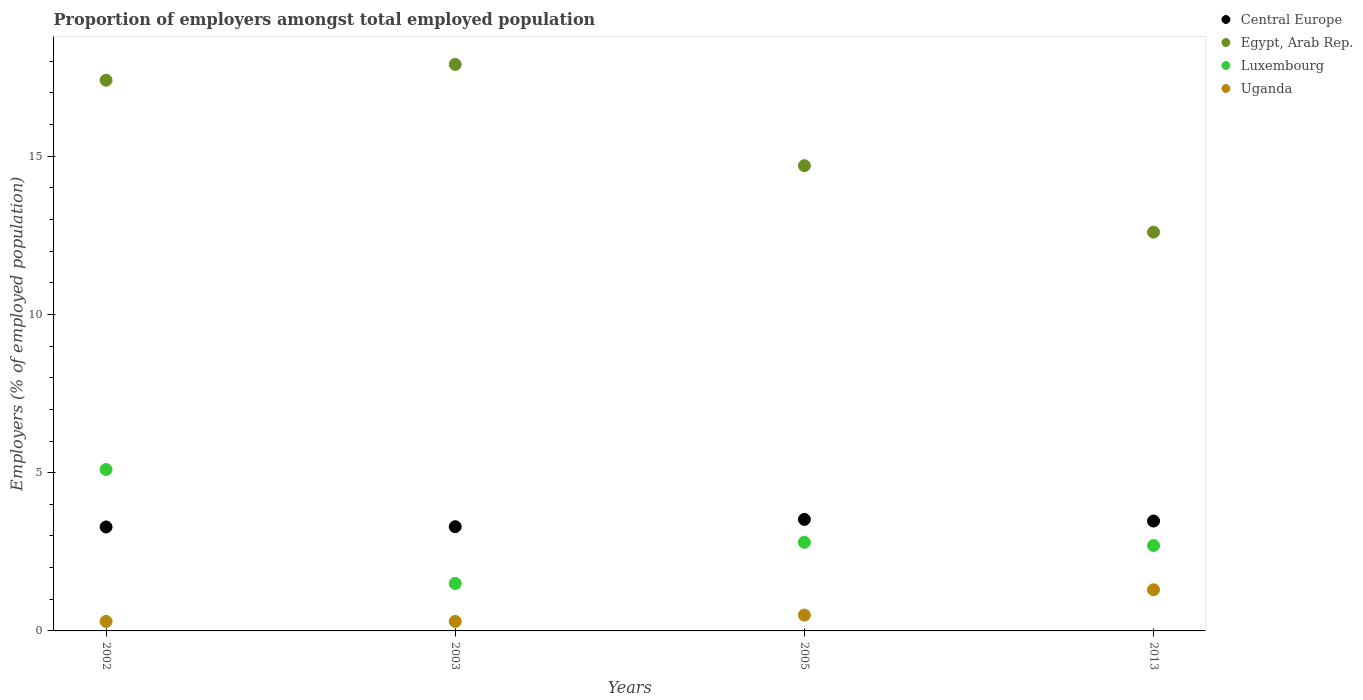How many different coloured dotlines are there?
Give a very brief answer. 4. What is the proportion of employers in Luxembourg in 2003?
Provide a succinct answer. 1.5. Across all years, what is the maximum proportion of employers in Uganda?
Offer a terse response. 1.3. Across all years, what is the minimum proportion of employers in Uganda?
Offer a terse response. 0.3. In which year was the proportion of employers in Luxembourg minimum?
Give a very brief answer. 2003. What is the total proportion of employers in Central Europe in the graph?
Offer a terse response. 13.57. What is the difference between the proportion of employers in Uganda in 2002 and that in 2013?
Offer a terse response. -1. What is the difference between the proportion of employers in Uganda in 2003 and the proportion of employers in Luxembourg in 2013?
Provide a short and direct response. -2.4. What is the average proportion of employers in Egypt, Arab Rep. per year?
Your answer should be compact. 15.65. In the year 2013, what is the difference between the proportion of employers in Egypt, Arab Rep. and proportion of employers in Luxembourg?
Provide a short and direct response. 9.9. What is the ratio of the proportion of employers in Luxembourg in 2003 to that in 2005?
Keep it short and to the point. 0.54. Is the difference between the proportion of employers in Egypt, Arab Rep. in 2002 and 2013 greater than the difference between the proportion of employers in Luxembourg in 2002 and 2013?
Make the answer very short. Yes. What is the difference between the highest and the second highest proportion of employers in Luxembourg?
Keep it short and to the point. 2.3. What is the difference between the highest and the lowest proportion of employers in Central Europe?
Provide a succinct answer. 0.24. In how many years, is the proportion of employers in Luxembourg greater than the average proportion of employers in Luxembourg taken over all years?
Offer a terse response. 1. Is it the case that in every year, the sum of the proportion of employers in Egypt, Arab Rep. and proportion of employers in Luxembourg  is greater than the sum of proportion of employers in Uganda and proportion of employers in Central Europe?
Provide a succinct answer. Yes. Does the proportion of employers in Luxembourg monotonically increase over the years?
Make the answer very short. No. Is the proportion of employers in Luxembourg strictly greater than the proportion of employers in Central Europe over the years?
Give a very brief answer. No. Is the proportion of employers in Central Europe strictly less than the proportion of employers in Luxembourg over the years?
Keep it short and to the point. No. How many dotlines are there?
Your answer should be compact. 4. What is the difference between two consecutive major ticks on the Y-axis?
Keep it short and to the point. 5. Are the values on the major ticks of Y-axis written in scientific E-notation?
Your answer should be very brief. No. Does the graph contain any zero values?
Offer a terse response. No. Where does the legend appear in the graph?
Your answer should be compact. Top right. How many legend labels are there?
Give a very brief answer. 4. What is the title of the graph?
Keep it short and to the point. Proportion of employers amongst total employed population. What is the label or title of the X-axis?
Make the answer very short. Years. What is the label or title of the Y-axis?
Offer a very short reply. Employers (% of employed population). What is the Employers (% of employed population) of Central Europe in 2002?
Your answer should be compact. 3.28. What is the Employers (% of employed population) of Egypt, Arab Rep. in 2002?
Your answer should be compact. 17.4. What is the Employers (% of employed population) in Luxembourg in 2002?
Make the answer very short. 5.1. What is the Employers (% of employed population) of Uganda in 2002?
Make the answer very short. 0.3. What is the Employers (% of employed population) in Central Europe in 2003?
Provide a short and direct response. 3.29. What is the Employers (% of employed population) in Egypt, Arab Rep. in 2003?
Provide a short and direct response. 17.9. What is the Employers (% of employed population) in Luxembourg in 2003?
Your answer should be very brief. 1.5. What is the Employers (% of employed population) of Uganda in 2003?
Offer a terse response. 0.3. What is the Employers (% of employed population) of Central Europe in 2005?
Keep it short and to the point. 3.52. What is the Employers (% of employed population) in Egypt, Arab Rep. in 2005?
Keep it short and to the point. 14.7. What is the Employers (% of employed population) of Luxembourg in 2005?
Keep it short and to the point. 2.8. What is the Employers (% of employed population) in Central Europe in 2013?
Ensure brevity in your answer.  3.47. What is the Employers (% of employed population) in Egypt, Arab Rep. in 2013?
Provide a succinct answer. 12.6. What is the Employers (% of employed population) in Luxembourg in 2013?
Keep it short and to the point. 2.7. What is the Employers (% of employed population) in Uganda in 2013?
Keep it short and to the point. 1.3. Across all years, what is the maximum Employers (% of employed population) in Central Europe?
Provide a short and direct response. 3.52. Across all years, what is the maximum Employers (% of employed population) in Egypt, Arab Rep.?
Give a very brief answer. 17.9. Across all years, what is the maximum Employers (% of employed population) in Luxembourg?
Ensure brevity in your answer.  5.1. Across all years, what is the maximum Employers (% of employed population) of Uganda?
Ensure brevity in your answer.  1.3. Across all years, what is the minimum Employers (% of employed population) in Central Europe?
Your answer should be compact. 3.28. Across all years, what is the minimum Employers (% of employed population) of Egypt, Arab Rep.?
Provide a short and direct response. 12.6. Across all years, what is the minimum Employers (% of employed population) of Uganda?
Your answer should be compact. 0.3. What is the total Employers (% of employed population) in Central Europe in the graph?
Give a very brief answer. 13.57. What is the total Employers (% of employed population) in Egypt, Arab Rep. in the graph?
Your answer should be very brief. 62.6. What is the difference between the Employers (% of employed population) in Central Europe in 2002 and that in 2003?
Ensure brevity in your answer.  -0.01. What is the difference between the Employers (% of employed population) in Egypt, Arab Rep. in 2002 and that in 2003?
Your answer should be very brief. -0.5. What is the difference between the Employers (% of employed population) in Uganda in 2002 and that in 2003?
Your answer should be compact. 0. What is the difference between the Employers (% of employed population) in Central Europe in 2002 and that in 2005?
Provide a succinct answer. -0.24. What is the difference between the Employers (% of employed population) in Luxembourg in 2002 and that in 2005?
Offer a very short reply. 2.3. What is the difference between the Employers (% of employed population) of Uganda in 2002 and that in 2005?
Offer a terse response. -0.2. What is the difference between the Employers (% of employed population) in Central Europe in 2002 and that in 2013?
Your answer should be very brief. -0.19. What is the difference between the Employers (% of employed population) of Luxembourg in 2002 and that in 2013?
Your answer should be very brief. 2.4. What is the difference between the Employers (% of employed population) of Central Europe in 2003 and that in 2005?
Ensure brevity in your answer.  -0.23. What is the difference between the Employers (% of employed population) in Egypt, Arab Rep. in 2003 and that in 2005?
Your response must be concise. 3.2. What is the difference between the Employers (% of employed population) in Uganda in 2003 and that in 2005?
Offer a terse response. -0.2. What is the difference between the Employers (% of employed population) of Central Europe in 2003 and that in 2013?
Your answer should be compact. -0.18. What is the difference between the Employers (% of employed population) of Egypt, Arab Rep. in 2003 and that in 2013?
Your answer should be very brief. 5.3. What is the difference between the Employers (% of employed population) of Luxembourg in 2003 and that in 2013?
Offer a terse response. -1.2. What is the difference between the Employers (% of employed population) of Central Europe in 2005 and that in 2013?
Make the answer very short. 0.05. What is the difference between the Employers (% of employed population) in Egypt, Arab Rep. in 2005 and that in 2013?
Offer a terse response. 2.1. What is the difference between the Employers (% of employed population) of Uganda in 2005 and that in 2013?
Your response must be concise. -0.8. What is the difference between the Employers (% of employed population) of Central Europe in 2002 and the Employers (% of employed population) of Egypt, Arab Rep. in 2003?
Ensure brevity in your answer.  -14.62. What is the difference between the Employers (% of employed population) of Central Europe in 2002 and the Employers (% of employed population) of Luxembourg in 2003?
Provide a succinct answer. 1.78. What is the difference between the Employers (% of employed population) in Central Europe in 2002 and the Employers (% of employed population) in Uganda in 2003?
Your answer should be very brief. 2.98. What is the difference between the Employers (% of employed population) in Egypt, Arab Rep. in 2002 and the Employers (% of employed population) in Uganda in 2003?
Your answer should be compact. 17.1. What is the difference between the Employers (% of employed population) of Luxembourg in 2002 and the Employers (% of employed population) of Uganda in 2003?
Your answer should be compact. 4.8. What is the difference between the Employers (% of employed population) in Central Europe in 2002 and the Employers (% of employed population) in Egypt, Arab Rep. in 2005?
Offer a very short reply. -11.42. What is the difference between the Employers (% of employed population) of Central Europe in 2002 and the Employers (% of employed population) of Luxembourg in 2005?
Offer a very short reply. 0.48. What is the difference between the Employers (% of employed population) of Central Europe in 2002 and the Employers (% of employed population) of Uganda in 2005?
Your answer should be very brief. 2.78. What is the difference between the Employers (% of employed population) of Egypt, Arab Rep. in 2002 and the Employers (% of employed population) of Luxembourg in 2005?
Ensure brevity in your answer.  14.6. What is the difference between the Employers (% of employed population) in Central Europe in 2002 and the Employers (% of employed population) in Egypt, Arab Rep. in 2013?
Provide a short and direct response. -9.32. What is the difference between the Employers (% of employed population) of Central Europe in 2002 and the Employers (% of employed population) of Luxembourg in 2013?
Provide a short and direct response. 0.58. What is the difference between the Employers (% of employed population) of Central Europe in 2002 and the Employers (% of employed population) of Uganda in 2013?
Provide a short and direct response. 1.98. What is the difference between the Employers (% of employed population) of Egypt, Arab Rep. in 2002 and the Employers (% of employed population) of Luxembourg in 2013?
Your answer should be compact. 14.7. What is the difference between the Employers (% of employed population) in Egypt, Arab Rep. in 2002 and the Employers (% of employed population) in Uganda in 2013?
Your response must be concise. 16.1. What is the difference between the Employers (% of employed population) in Central Europe in 2003 and the Employers (% of employed population) in Egypt, Arab Rep. in 2005?
Offer a terse response. -11.41. What is the difference between the Employers (% of employed population) in Central Europe in 2003 and the Employers (% of employed population) in Luxembourg in 2005?
Ensure brevity in your answer.  0.49. What is the difference between the Employers (% of employed population) of Central Europe in 2003 and the Employers (% of employed population) of Uganda in 2005?
Provide a short and direct response. 2.79. What is the difference between the Employers (% of employed population) in Egypt, Arab Rep. in 2003 and the Employers (% of employed population) in Luxembourg in 2005?
Ensure brevity in your answer.  15.1. What is the difference between the Employers (% of employed population) of Egypt, Arab Rep. in 2003 and the Employers (% of employed population) of Uganda in 2005?
Keep it short and to the point. 17.4. What is the difference between the Employers (% of employed population) of Central Europe in 2003 and the Employers (% of employed population) of Egypt, Arab Rep. in 2013?
Keep it short and to the point. -9.31. What is the difference between the Employers (% of employed population) in Central Europe in 2003 and the Employers (% of employed population) in Luxembourg in 2013?
Keep it short and to the point. 0.59. What is the difference between the Employers (% of employed population) of Central Europe in 2003 and the Employers (% of employed population) of Uganda in 2013?
Your answer should be compact. 1.99. What is the difference between the Employers (% of employed population) of Luxembourg in 2003 and the Employers (% of employed population) of Uganda in 2013?
Offer a very short reply. 0.2. What is the difference between the Employers (% of employed population) in Central Europe in 2005 and the Employers (% of employed population) in Egypt, Arab Rep. in 2013?
Give a very brief answer. -9.08. What is the difference between the Employers (% of employed population) in Central Europe in 2005 and the Employers (% of employed population) in Luxembourg in 2013?
Ensure brevity in your answer.  0.82. What is the difference between the Employers (% of employed population) of Central Europe in 2005 and the Employers (% of employed population) of Uganda in 2013?
Keep it short and to the point. 2.22. What is the difference between the Employers (% of employed population) of Egypt, Arab Rep. in 2005 and the Employers (% of employed population) of Uganda in 2013?
Ensure brevity in your answer.  13.4. What is the average Employers (% of employed population) of Central Europe per year?
Give a very brief answer. 3.39. What is the average Employers (% of employed population) in Egypt, Arab Rep. per year?
Offer a very short reply. 15.65. What is the average Employers (% of employed population) of Luxembourg per year?
Give a very brief answer. 3.02. In the year 2002, what is the difference between the Employers (% of employed population) of Central Europe and Employers (% of employed population) of Egypt, Arab Rep.?
Your answer should be very brief. -14.12. In the year 2002, what is the difference between the Employers (% of employed population) of Central Europe and Employers (% of employed population) of Luxembourg?
Your response must be concise. -1.82. In the year 2002, what is the difference between the Employers (% of employed population) of Central Europe and Employers (% of employed population) of Uganda?
Ensure brevity in your answer.  2.98. In the year 2002, what is the difference between the Employers (% of employed population) of Egypt, Arab Rep. and Employers (% of employed population) of Luxembourg?
Offer a terse response. 12.3. In the year 2002, what is the difference between the Employers (% of employed population) in Egypt, Arab Rep. and Employers (% of employed population) in Uganda?
Provide a short and direct response. 17.1. In the year 2003, what is the difference between the Employers (% of employed population) of Central Europe and Employers (% of employed population) of Egypt, Arab Rep.?
Make the answer very short. -14.61. In the year 2003, what is the difference between the Employers (% of employed population) in Central Europe and Employers (% of employed population) in Luxembourg?
Provide a short and direct response. 1.79. In the year 2003, what is the difference between the Employers (% of employed population) of Central Europe and Employers (% of employed population) of Uganda?
Provide a succinct answer. 2.99. In the year 2005, what is the difference between the Employers (% of employed population) in Central Europe and Employers (% of employed population) in Egypt, Arab Rep.?
Ensure brevity in your answer.  -11.18. In the year 2005, what is the difference between the Employers (% of employed population) of Central Europe and Employers (% of employed population) of Luxembourg?
Ensure brevity in your answer.  0.72. In the year 2005, what is the difference between the Employers (% of employed population) in Central Europe and Employers (% of employed population) in Uganda?
Your response must be concise. 3.02. In the year 2013, what is the difference between the Employers (% of employed population) of Central Europe and Employers (% of employed population) of Egypt, Arab Rep.?
Provide a succinct answer. -9.13. In the year 2013, what is the difference between the Employers (% of employed population) of Central Europe and Employers (% of employed population) of Luxembourg?
Your response must be concise. 0.77. In the year 2013, what is the difference between the Employers (% of employed population) of Central Europe and Employers (% of employed population) of Uganda?
Offer a very short reply. 2.17. In the year 2013, what is the difference between the Employers (% of employed population) of Luxembourg and Employers (% of employed population) of Uganda?
Provide a succinct answer. 1.4. What is the ratio of the Employers (% of employed population) of Egypt, Arab Rep. in 2002 to that in 2003?
Make the answer very short. 0.97. What is the ratio of the Employers (% of employed population) in Luxembourg in 2002 to that in 2003?
Your response must be concise. 3.4. What is the ratio of the Employers (% of employed population) in Central Europe in 2002 to that in 2005?
Give a very brief answer. 0.93. What is the ratio of the Employers (% of employed population) in Egypt, Arab Rep. in 2002 to that in 2005?
Offer a terse response. 1.18. What is the ratio of the Employers (% of employed population) of Luxembourg in 2002 to that in 2005?
Provide a succinct answer. 1.82. What is the ratio of the Employers (% of employed population) in Uganda in 2002 to that in 2005?
Provide a short and direct response. 0.6. What is the ratio of the Employers (% of employed population) of Central Europe in 2002 to that in 2013?
Provide a succinct answer. 0.95. What is the ratio of the Employers (% of employed population) in Egypt, Arab Rep. in 2002 to that in 2013?
Offer a terse response. 1.38. What is the ratio of the Employers (% of employed population) of Luxembourg in 2002 to that in 2013?
Keep it short and to the point. 1.89. What is the ratio of the Employers (% of employed population) in Uganda in 2002 to that in 2013?
Your answer should be very brief. 0.23. What is the ratio of the Employers (% of employed population) in Central Europe in 2003 to that in 2005?
Provide a short and direct response. 0.93. What is the ratio of the Employers (% of employed population) in Egypt, Arab Rep. in 2003 to that in 2005?
Give a very brief answer. 1.22. What is the ratio of the Employers (% of employed population) in Luxembourg in 2003 to that in 2005?
Your answer should be compact. 0.54. What is the ratio of the Employers (% of employed population) in Uganda in 2003 to that in 2005?
Your answer should be compact. 0.6. What is the ratio of the Employers (% of employed population) of Central Europe in 2003 to that in 2013?
Make the answer very short. 0.95. What is the ratio of the Employers (% of employed population) in Egypt, Arab Rep. in 2003 to that in 2013?
Your answer should be very brief. 1.42. What is the ratio of the Employers (% of employed population) in Luxembourg in 2003 to that in 2013?
Your response must be concise. 0.56. What is the ratio of the Employers (% of employed population) in Uganda in 2003 to that in 2013?
Keep it short and to the point. 0.23. What is the ratio of the Employers (% of employed population) of Central Europe in 2005 to that in 2013?
Your answer should be very brief. 1.01. What is the ratio of the Employers (% of employed population) in Luxembourg in 2005 to that in 2013?
Ensure brevity in your answer.  1.04. What is the ratio of the Employers (% of employed population) in Uganda in 2005 to that in 2013?
Ensure brevity in your answer.  0.38. What is the difference between the highest and the second highest Employers (% of employed population) in Central Europe?
Offer a terse response. 0.05. What is the difference between the highest and the second highest Employers (% of employed population) in Luxembourg?
Offer a terse response. 2.3. What is the difference between the highest and the second highest Employers (% of employed population) of Uganda?
Give a very brief answer. 0.8. What is the difference between the highest and the lowest Employers (% of employed population) in Central Europe?
Offer a very short reply. 0.24. What is the difference between the highest and the lowest Employers (% of employed population) of Luxembourg?
Your answer should be compact. 3.6. What is the difference between the highest and the lowest Employers (% of employed population) in Uganda?
Keep it short and to the point. 1. 